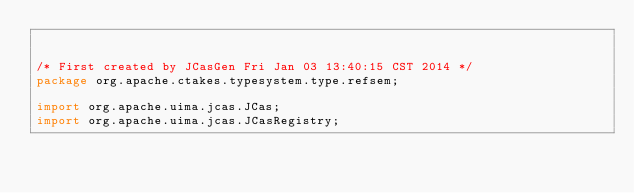Convert code to text. <code><loc_0><loc_0><loc_500><loc_500><_Java_>

/* First created by JCasGen Fri Jan 03 13:40:15 CST 2014 */
package org.apache.ctakes.typesystem.type.refsem;

import org.apache.uima.jcas.JCas; 
import org.apache.uima.jcas.JCasRegistry;</code> 